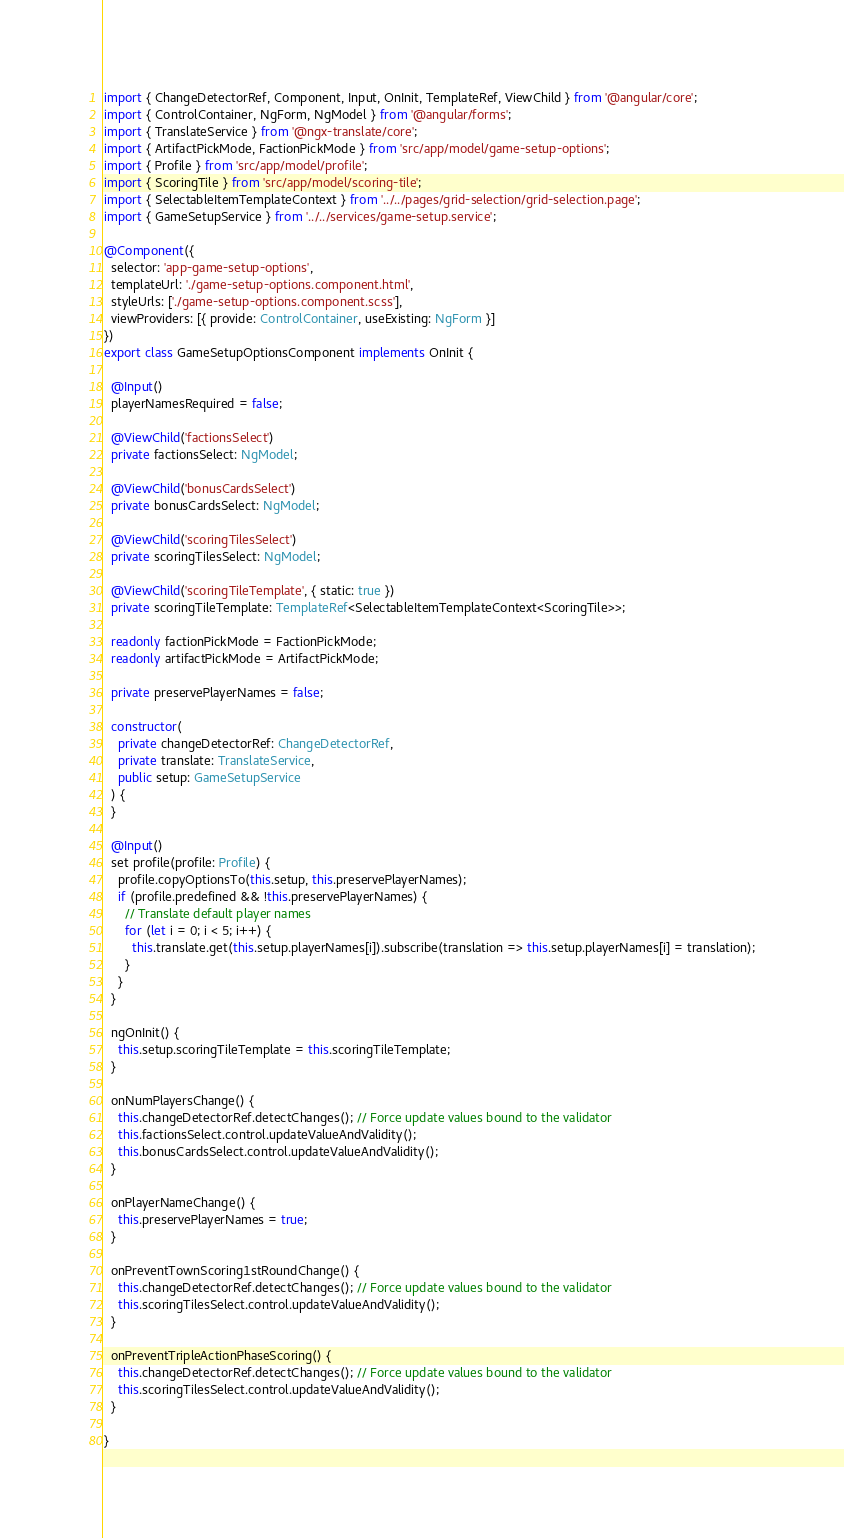<code> <loc_0><loc_0><loc_500><loc_500><_TypeScript_>import { ChangeDetectorRef, Component, Input, OnInit, TemplateRef, ViewChild } from '@angular/core';
import { ControlContainer, NgForm, NgModel } from '@angular/forms';
import { TranslateService } from '@ngx-translate/core';
import { ArtifactPickMode, FactionPickMode } from 'src/app/model/game-setup-options';
import { Profile } from 'src/app/model/profile';
import { ScoringTile } from 'src/app/model/scoring-tile';
import { SelectableItemTemplateContext } from '../../pages/grid-selection/grid-selection.page';
import { GameSetupService } from '../../services/game-setup.service';

@Component({
  selector: 'app-game-setup-options',
  templateUrl: './game-setup-options.component.html',
  styleUrls: ['./game-setup-options.component.scss'],
  viewProviders: [{ provide: ControlContainer, useExisting: NgForm }]
})
export class GameSetupOptionsComponent implements OnInit {

  @Input()
  playerNamesRequired = false;

  @ViewChild('factionsSelect')
  private factionsSelect: NgModel;

  @ViewChild('bonusCardsSelect')
  private bonusCardsSelect: NgModel;

  @ViewChild('scoringTilesSelect')
  private scoringTilesSelect: NgModel;

  @ViewChild('scoringTileTemplate', { static: true })
  private scoringTileTemplate: TemplateRef<SelectableItemTemplateContext<ScoringTile>>;

  readonly factionPickMode = FactionPickMode;
  readonly artifactPickMode = ArtifactPickMode;

  private preservePlayerNames = false;

  constructor(
    private changeDetectorRef: ChangeDetectorRef,
    private translate: TranslateService,
    public setup: GameSetupService
  ) {
  }

  @Input()
  set profile(profile: Profile) {
    profile.copyOptionsTo(this.setup, this.preservePlayerNames);
    if (profile.predefined && !this.preservePlayerNames) {
      // Translate default player names
      for (let i = 0; i < 5; i++) {
        this.translate.get(this.setup.playerNames[i]).subscribe(translation => this.setup.playerNames[i] = translation);
      }
    }
  }

  ngOnInit() {
    this.setup.scoringTileTemplate = this.scoringTileTemplate;
  }

  onNumPlayersChange() {
    this.changeDetectorRef.detectChanges(); // Force update values bound to the validator
    this.factionsSelect.control.updateValueAndValidity();
    this.bonusCardsSelect.control.updateValueAndValidity();
  }

  onPlayerNameChange() {
    this.preservePlayerNames = true;
  }

  onPreventTownScoring1stRoundChange() {
    this.changeDetectorRef.detectChanges(); // Force update values bound to the validator
    this.scoringTilesSelect.control.updateValueAndValidity();
  }

  onPreventTripleActionPhaseScoring() {
    this.changeDetectorRef.detectChanges(); // Force update values bound to the validator
    this.scoringTilesSelect.control.updateValueAndValidity();
  }

}
</code> 